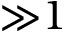<formula> <loc_0><loc_0><loc_500><loc_500>{ \gg } 1</formula> 